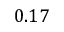Convert formula to latex. <formula><loc_0><loc_0><loc_500><loc_500>0 . 1 7</formula> 